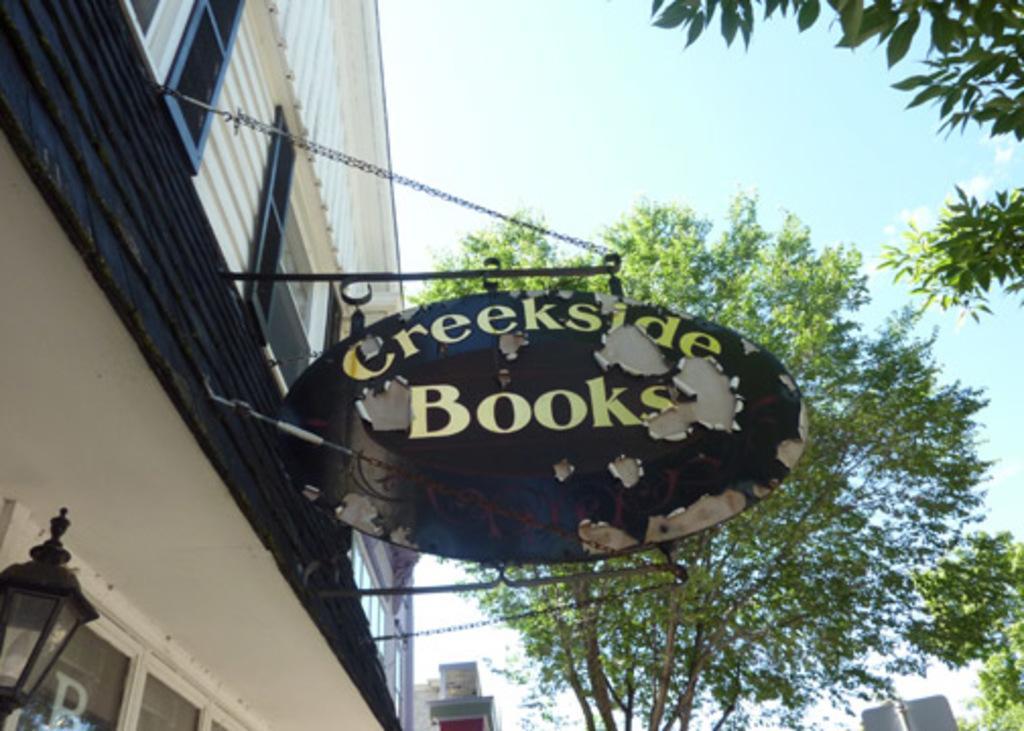How would you summarize this image in a sentence or two? In the picture we can see the name board which is fixed to the wall. Here we can see the lamp, I can see the buildings, trees and the sky in the background. 